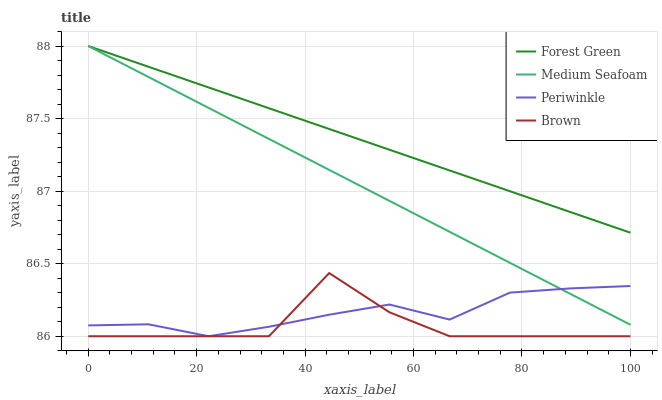Does Brown have the minimum area under the curve?
Answer yes or no. Yes. Does Forest Green have the maximum area under the curve?
Answer yes or no. Yes. Does Periwinkle have the minimum area under the curve?
Answer yes or no. No. Does Periwinkle have the maximum area under the curve?
Answer yes or no. No. Is Medium Seafoam the smoothest?
Answer yes or no. Yes. Is Brown the roughest?
Answer yes or no. Yes. Is Forest Green the smoothest?
Answer yes or no. No. Is Forest Green the roughest?
Answer yes or no. No. Does Brown have the lowest value?
Answer yes or no. Yes. Does Forest Green have the lowest value?
Answer yes or no. No. Does Medium Seafoam have the highest value?
Answer yes or no. Yes. Does Periwinkle have the highest value?
Answer yes or no. No. Is Brown less than Forest Green?
Answer yes or no. Yes. Is Forest Green greater than Brown?
Answer yes or no. Yes. Does Medium Seafoam intersect Periwinkle?
Answer yes or no. Yes. Is Medium Seafoam less than Periwinkle?
Answer yes or no. No. Is Medium Seafoam greater than Periwinkle?
Answer yes or no. No. Does Brown intersect Forest Green?
Answer yes or no. No. 